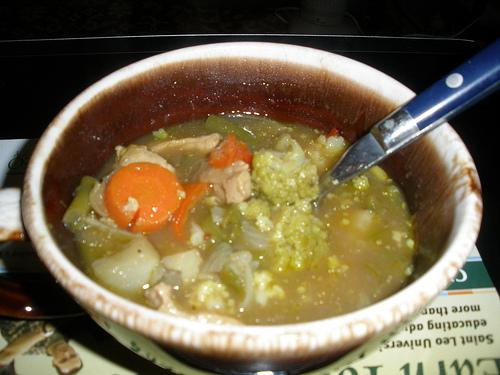Question: why is it so bright?
Choices:
A. The sun.
B. It is daylight.
C. Lights are on.
D. It is sunrise.
Answer with the letter. Answer: C Question: what is orange?
Choices:
A. The carrots.
B. Oranges.
C. The ball.
D. The book.
Answer with the letter. Answer: A Question: what is in the bowl?
Choices:
A. The soup.
B. Carrots.
C. The gloves.
D. Crayons.
Answer with the letter. Answer: A 